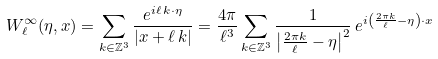Convert formula to latex. <formula><loc_0><loc_0><loc_500><loc_500>W _ { \ell } ^ { \infty } ( \eta , x ) = \sum _ { k \in \mathbb { Z } ^ { 3 } } \frac { e ^ { i \ell \, k \cdot \eta } } { | x + \ell \, k | } = \frac { 4 \pi } { \ell ^ { 3 } } \sum _ { k \in \mathbb { Z } ^ { 3 } } \frac { 1 } { \left | \frac { 2 \pi k } { \ell } - \eta \right | ^ { 2 } } \, e ^ { i \left ( \frac { 2 \pi k } { \ell } - \eta \right ) \cdot x }</formula> 